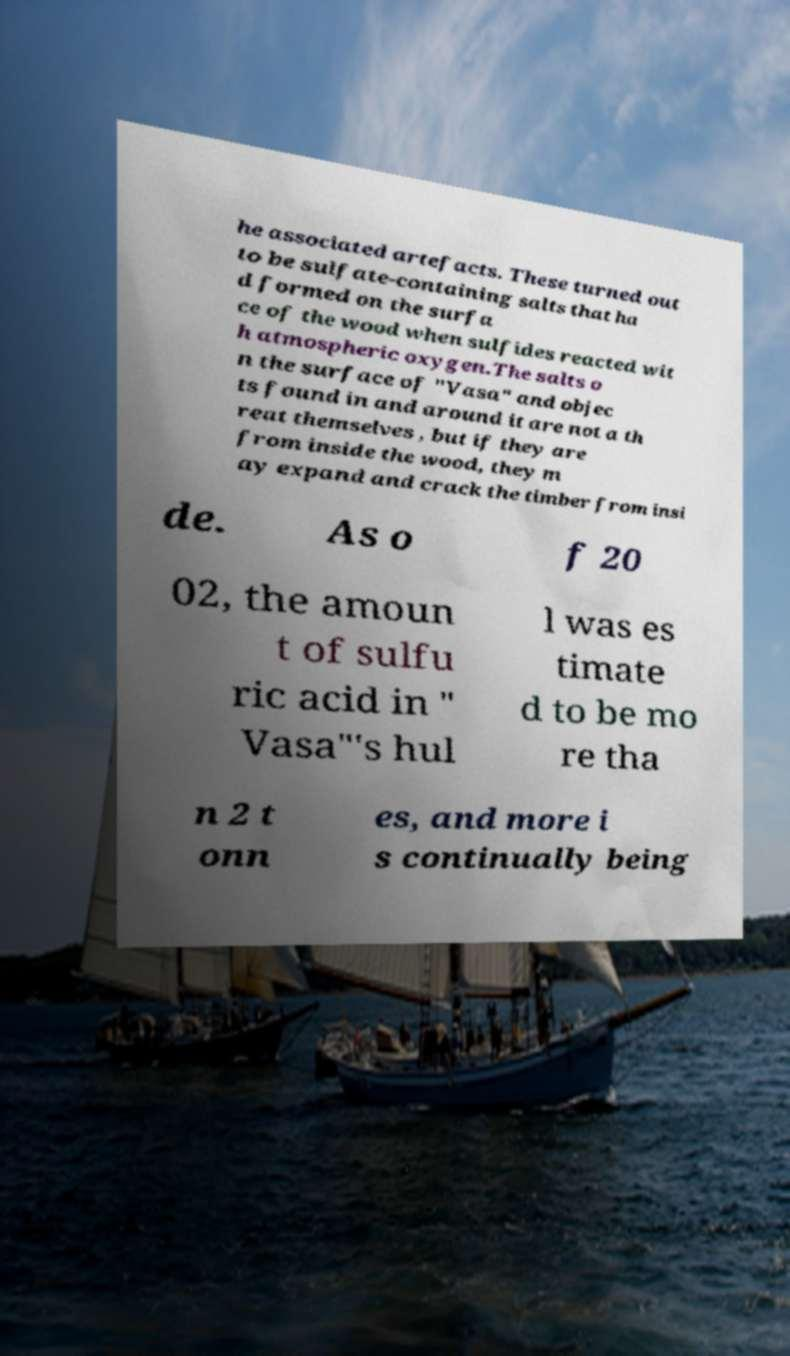Please read and relay the text visible in this image. What does it say? he associated artefacts. These turned out to be sulfate-containing salts that ha d formed on the surfa ce of the wood when sulfides reacted wit h atmospheric oxygen.The salts o n the surface of "Vasa" and objec ts found in and around it are not a th reat themselves , but if they are from inside the wood, they m ay expand and crack the timber from insi de. As o f 20 02, the amoun t of sulfu ric acid in " Vasa"'s hul l was es timate d to be mo re tha n 2 t onn es, and more i s continually being 